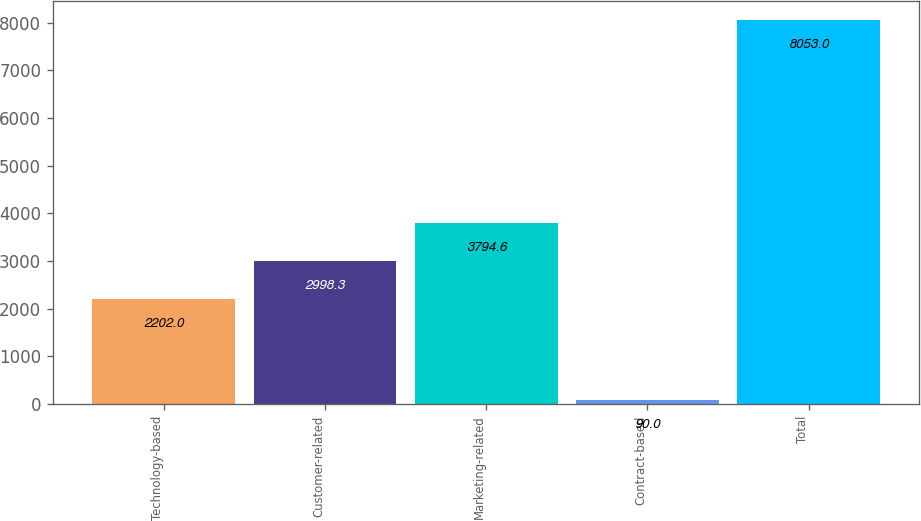Convert chart. <chart><loc_0><loc_0><loc_500><loc_500><bar_chart><fcel>Technology-based<fcel>Customer-related<fcel>Marketing-related<fcel>Contract-based<fcel>Total<nl><fcel>2202<fcel>2998.3<fcel>3794.6<fcel>90<fcel>8053<nl></chart> 